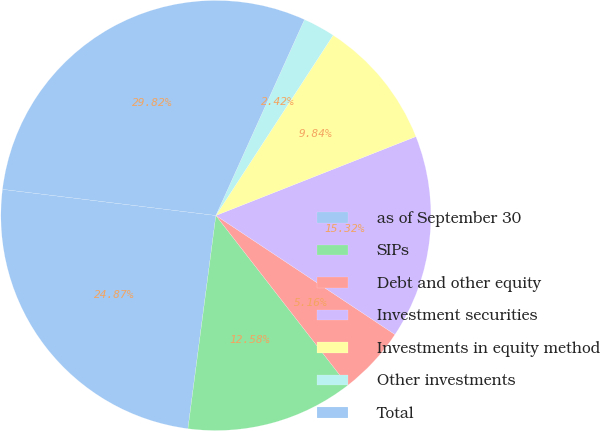Convert chart to OTSL. <chart><loc_0><loc_0><loc_500><loc_500><pie_chart><fcel>as of September 30<fcel>SIPs<fcel>Debt and other equity<fcel>Investment securities<fcel>Investments in equity method<fcel>Other investments<fcel>Total<nl><fcel>24.87%<fcel>12.58%<fcel>5.16%<fcel>15.32%<fcel>9.84%<fcel>2.42%<fcel>29.82%<nl></chart> 